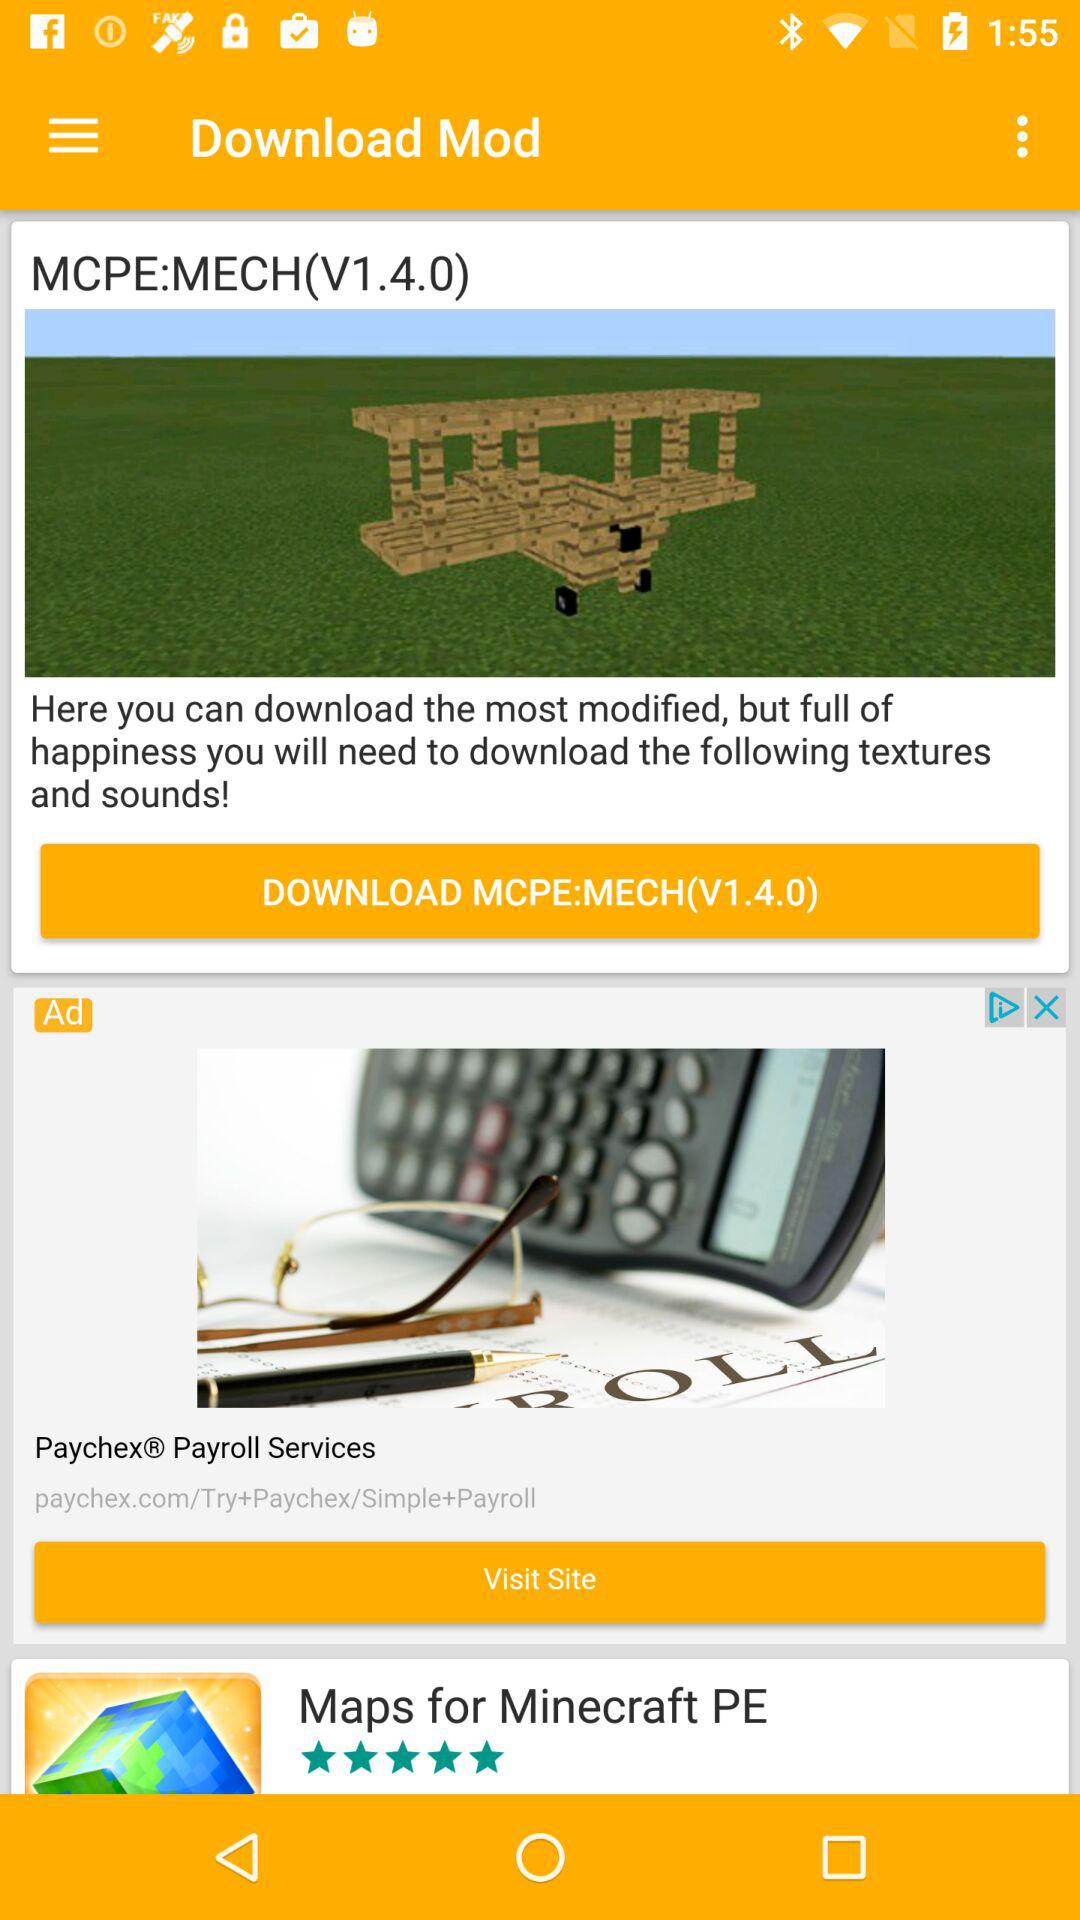What is the version of "MCPE:MECH"? The version is V1.4.0. 